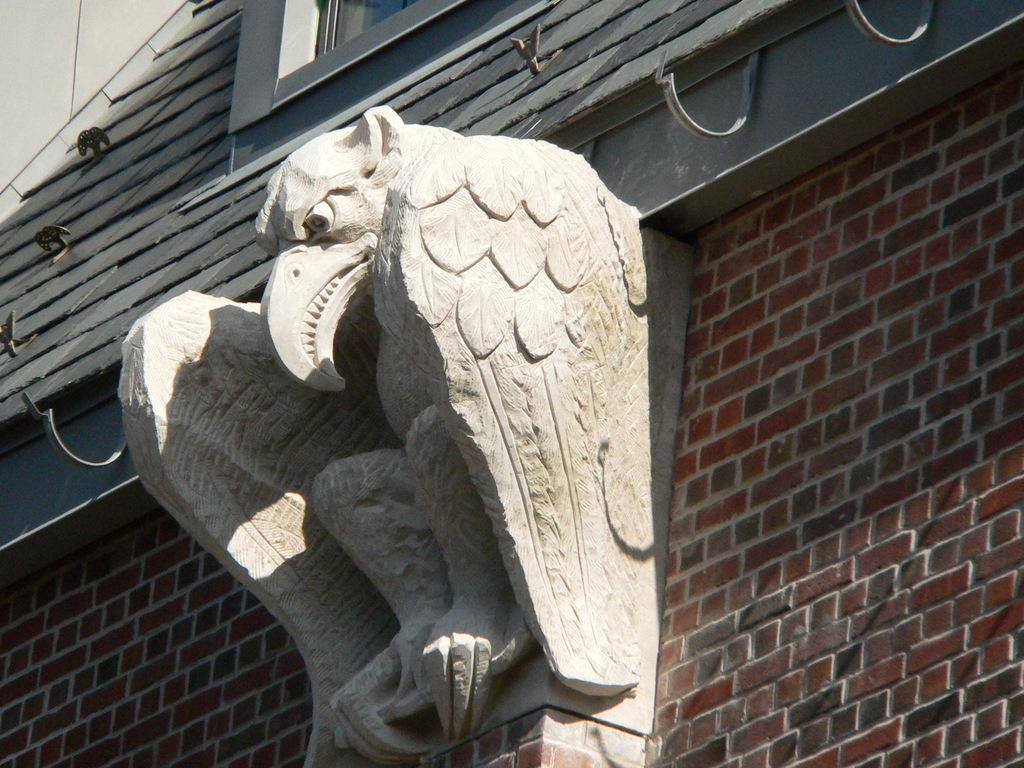What is the main subject in the center of the image? There is a sculpture in the center of the image. What can be seen in the background of the image? There is a wall and a window in the background of the image. How many apples are on the goat's journey in the image? There are no apples or goats present in the image. 